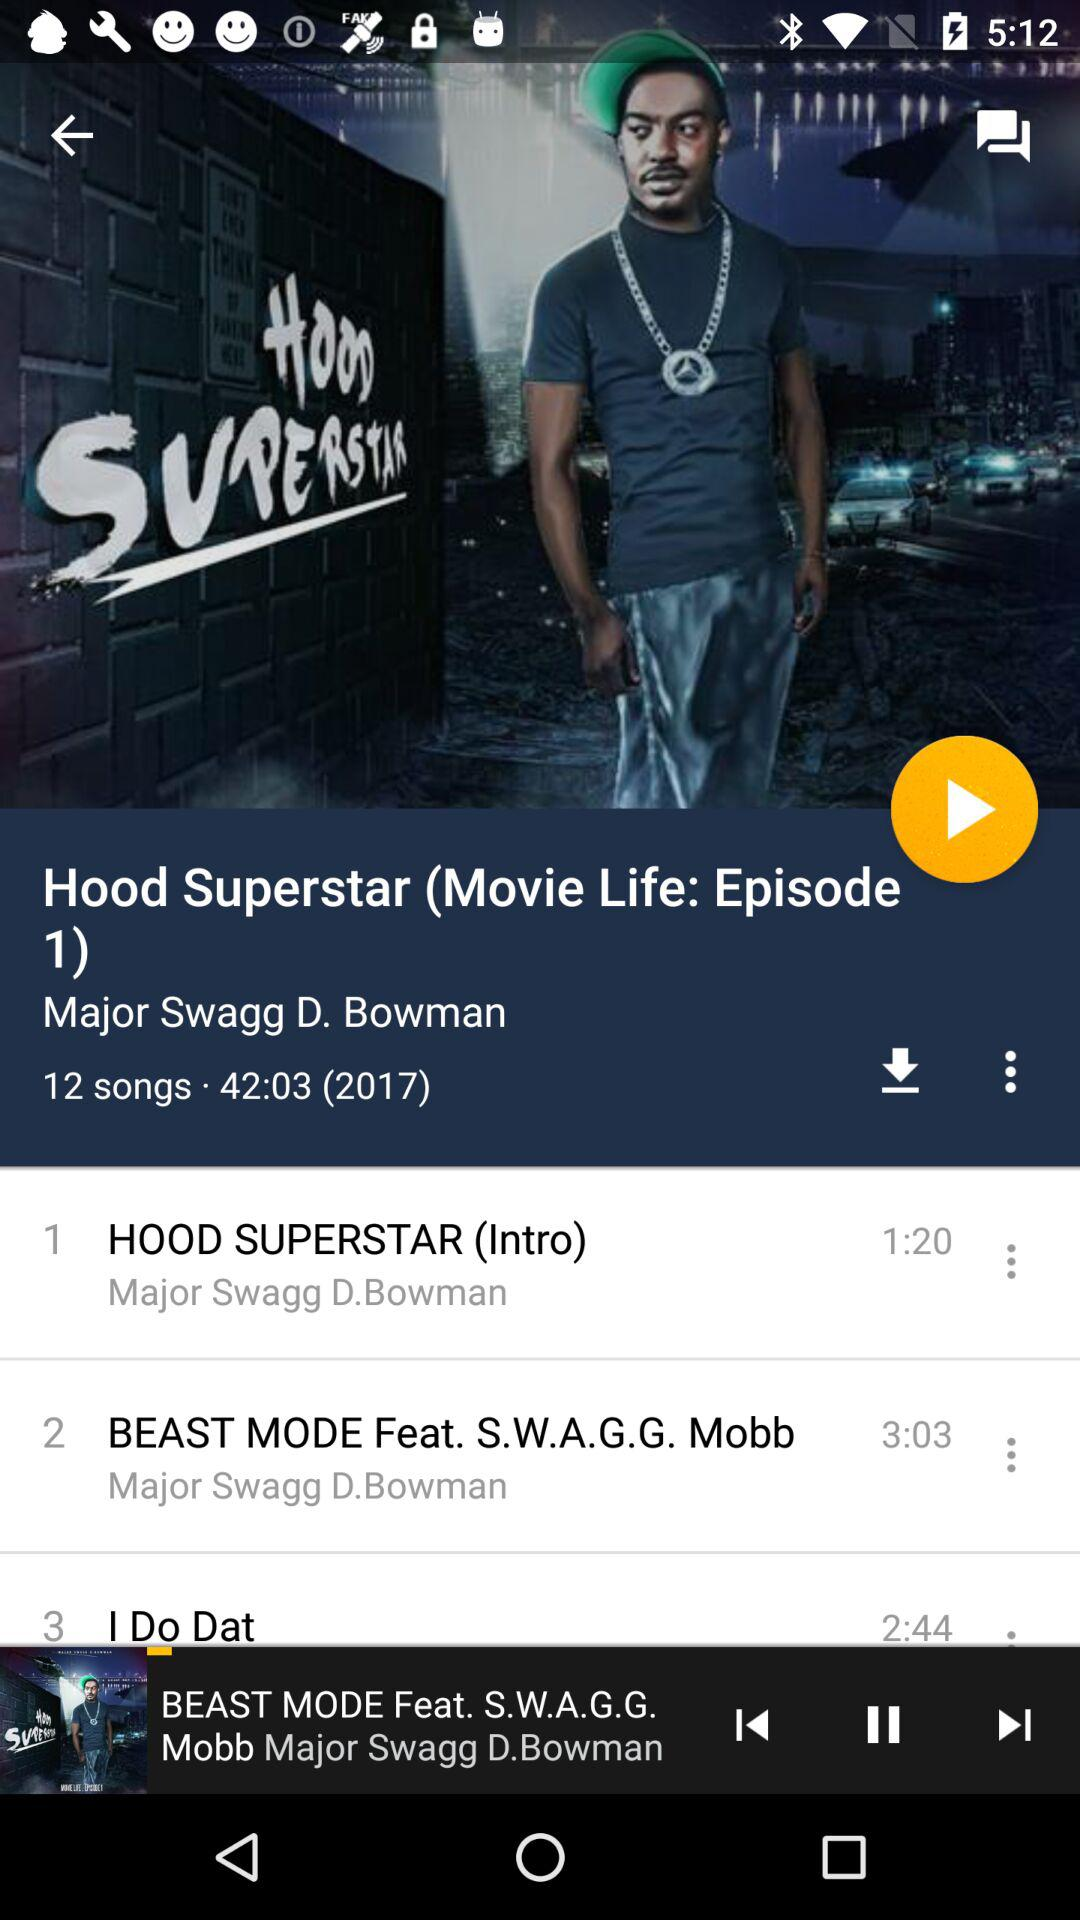What is the year? The year is 2017. 